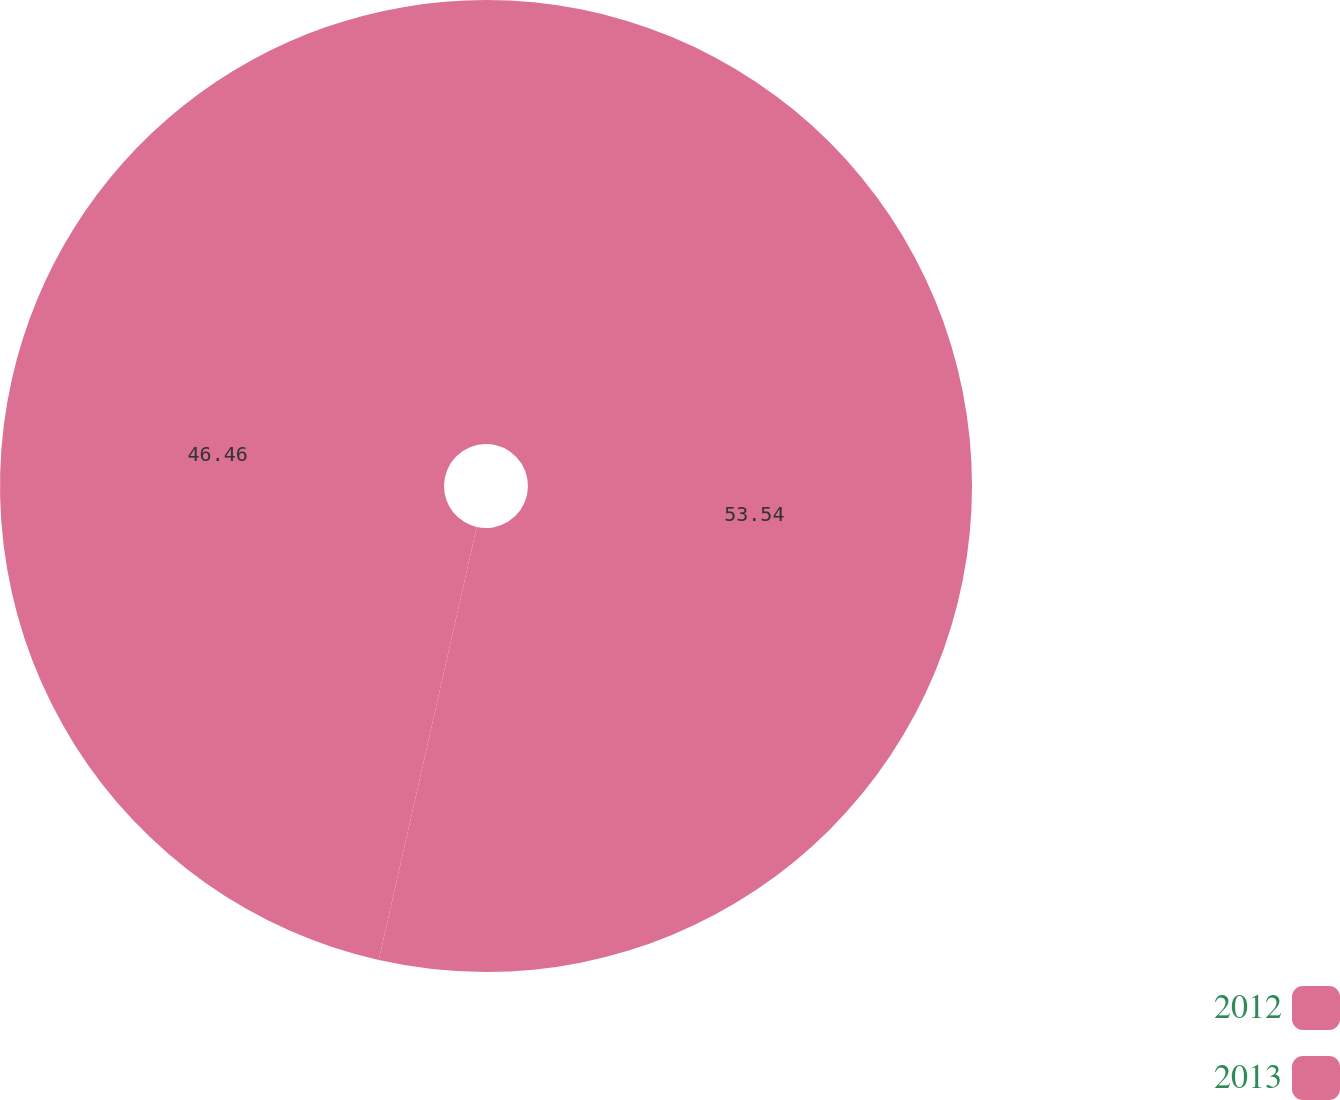<chart> <loc_0><loc_0><loc_500><loc_500><pie_chart><fcel>2012<fcel>2013<nl><fcel>53.54%<fcel>46.46%<nl></chart> 